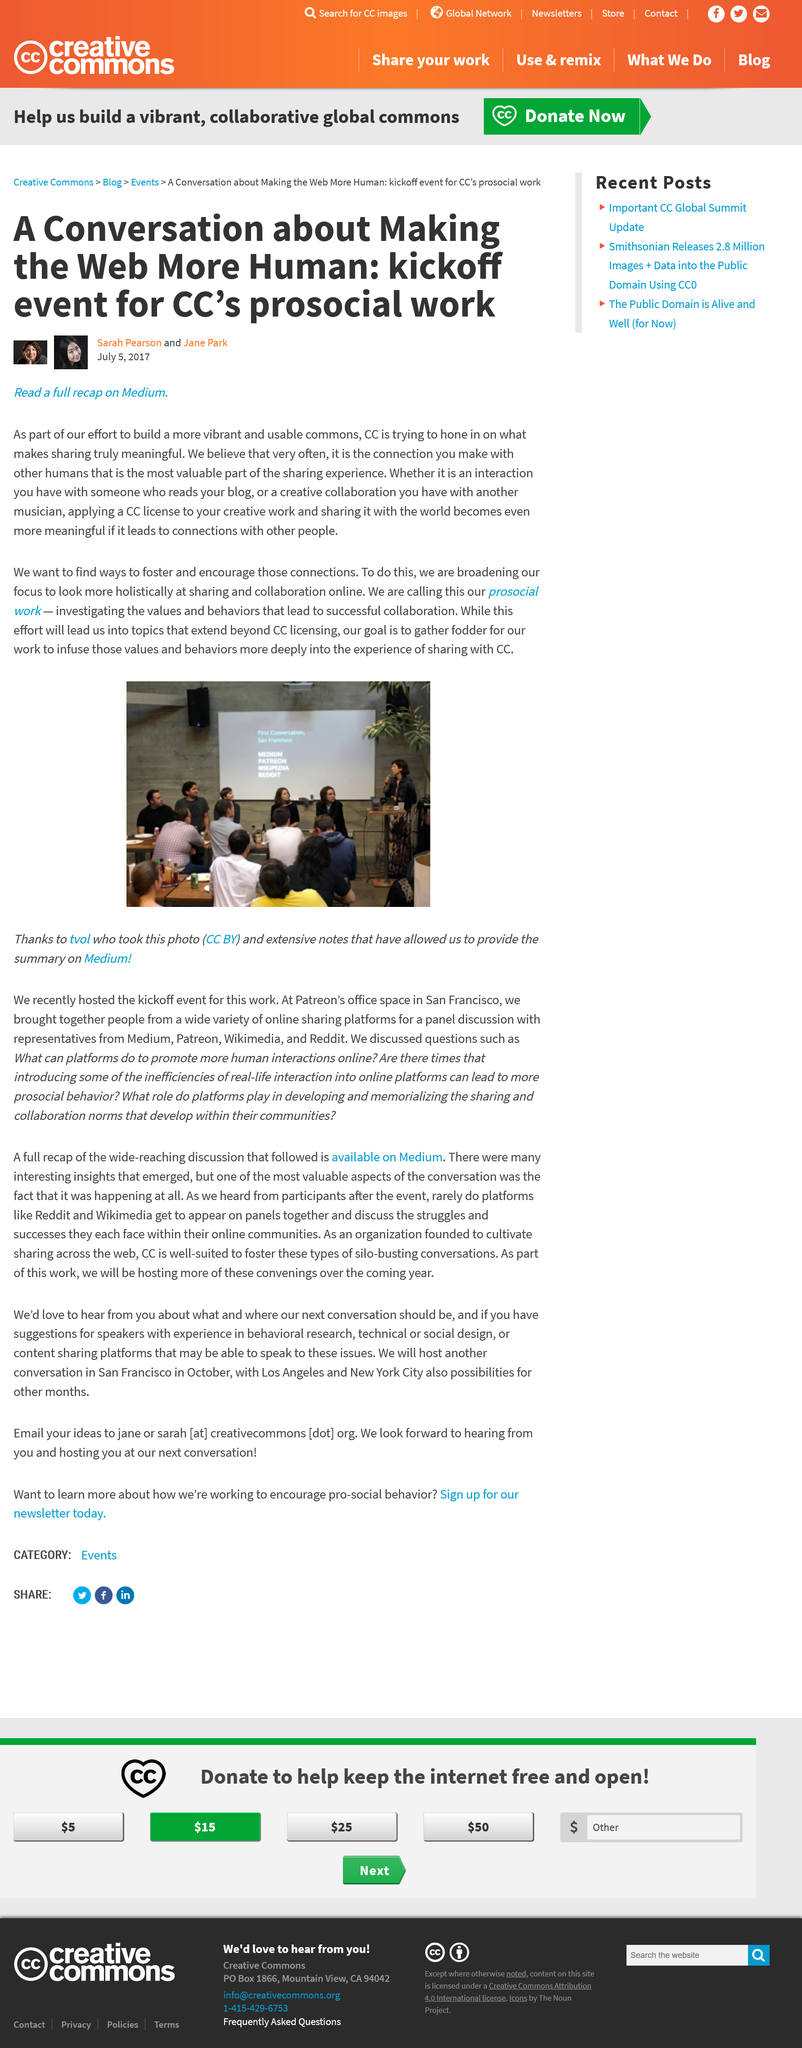Highlight a few significant elements in this photo. Prosocial work will investigate the values and behaviors of potential collaborators in order to facilitate successful collaboration. You can find more information about CC's Prosocial Work on the website Medium. Prosocial Work is the name of the new investigative work that CC is creating to build a more vibrant and usable commons. 